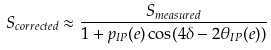<formula> <loc_0><loc_0><loc_500><loc_500>S _ { c o r r e c t e d } \approx \frac { S _ { m e a s u r e d } } { 1 + p _ { I P } ( e ) \cos ( 4 \delta - 2 \theta _ { I P } ( e ) ) }</formula> 